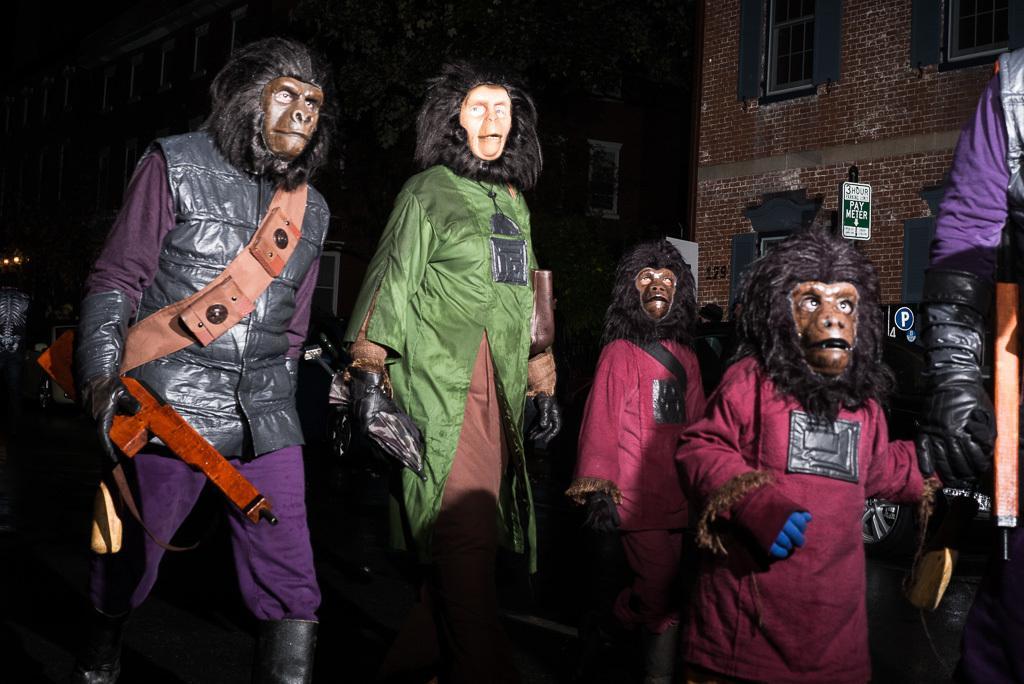Describe this image in one or two sentences. In the image in the center, we can see a few people are standing and they are in different costumes. And they are in monkey mask. In the background we can see buildings, sign boards etc. 